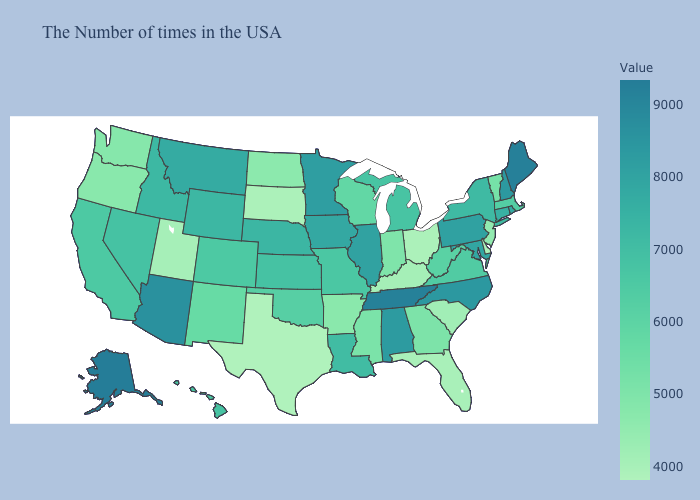Is the legend a continuous bar?
Be succinct. Yes. Which states have the lowest value in the Northeast?
Concise answer only. New Jersey. Among the states that border Alabama , which have the highest value?
Quick response, please. Tennessee. Does Texas have the lowest value in the South?
Keep it brief. Yes. Does the map have missing data?
Write a very short answer. No. Does Nevada have the lowest value in the West?
Keep it brief. No. Does New York have a lower value than Utah?
Concise answer only. No. 